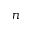<formula> <loc_0><loc_0><loc_500><loc_500>n</formula> 